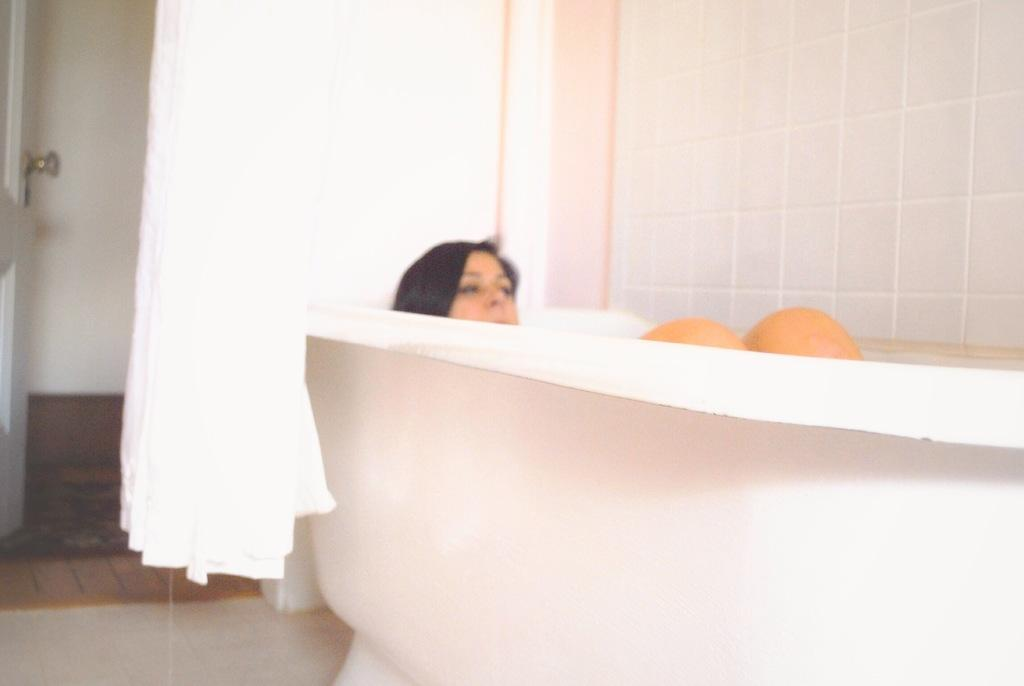What is the main subject of the image? The main subject of the image is a woman. What is the woman doing in the image? The woman is bathing in a bathtub. Can you describe any other objects or features in the image? Yes, there is a curtain in the middle of the image. What type of title can be seen on the chickens in the image? There are no chickens present in the image, so there is no title to be seen on them. What type of land can be seen in the image? The image does not show any land; it features a woman bathing in a bathtub. 